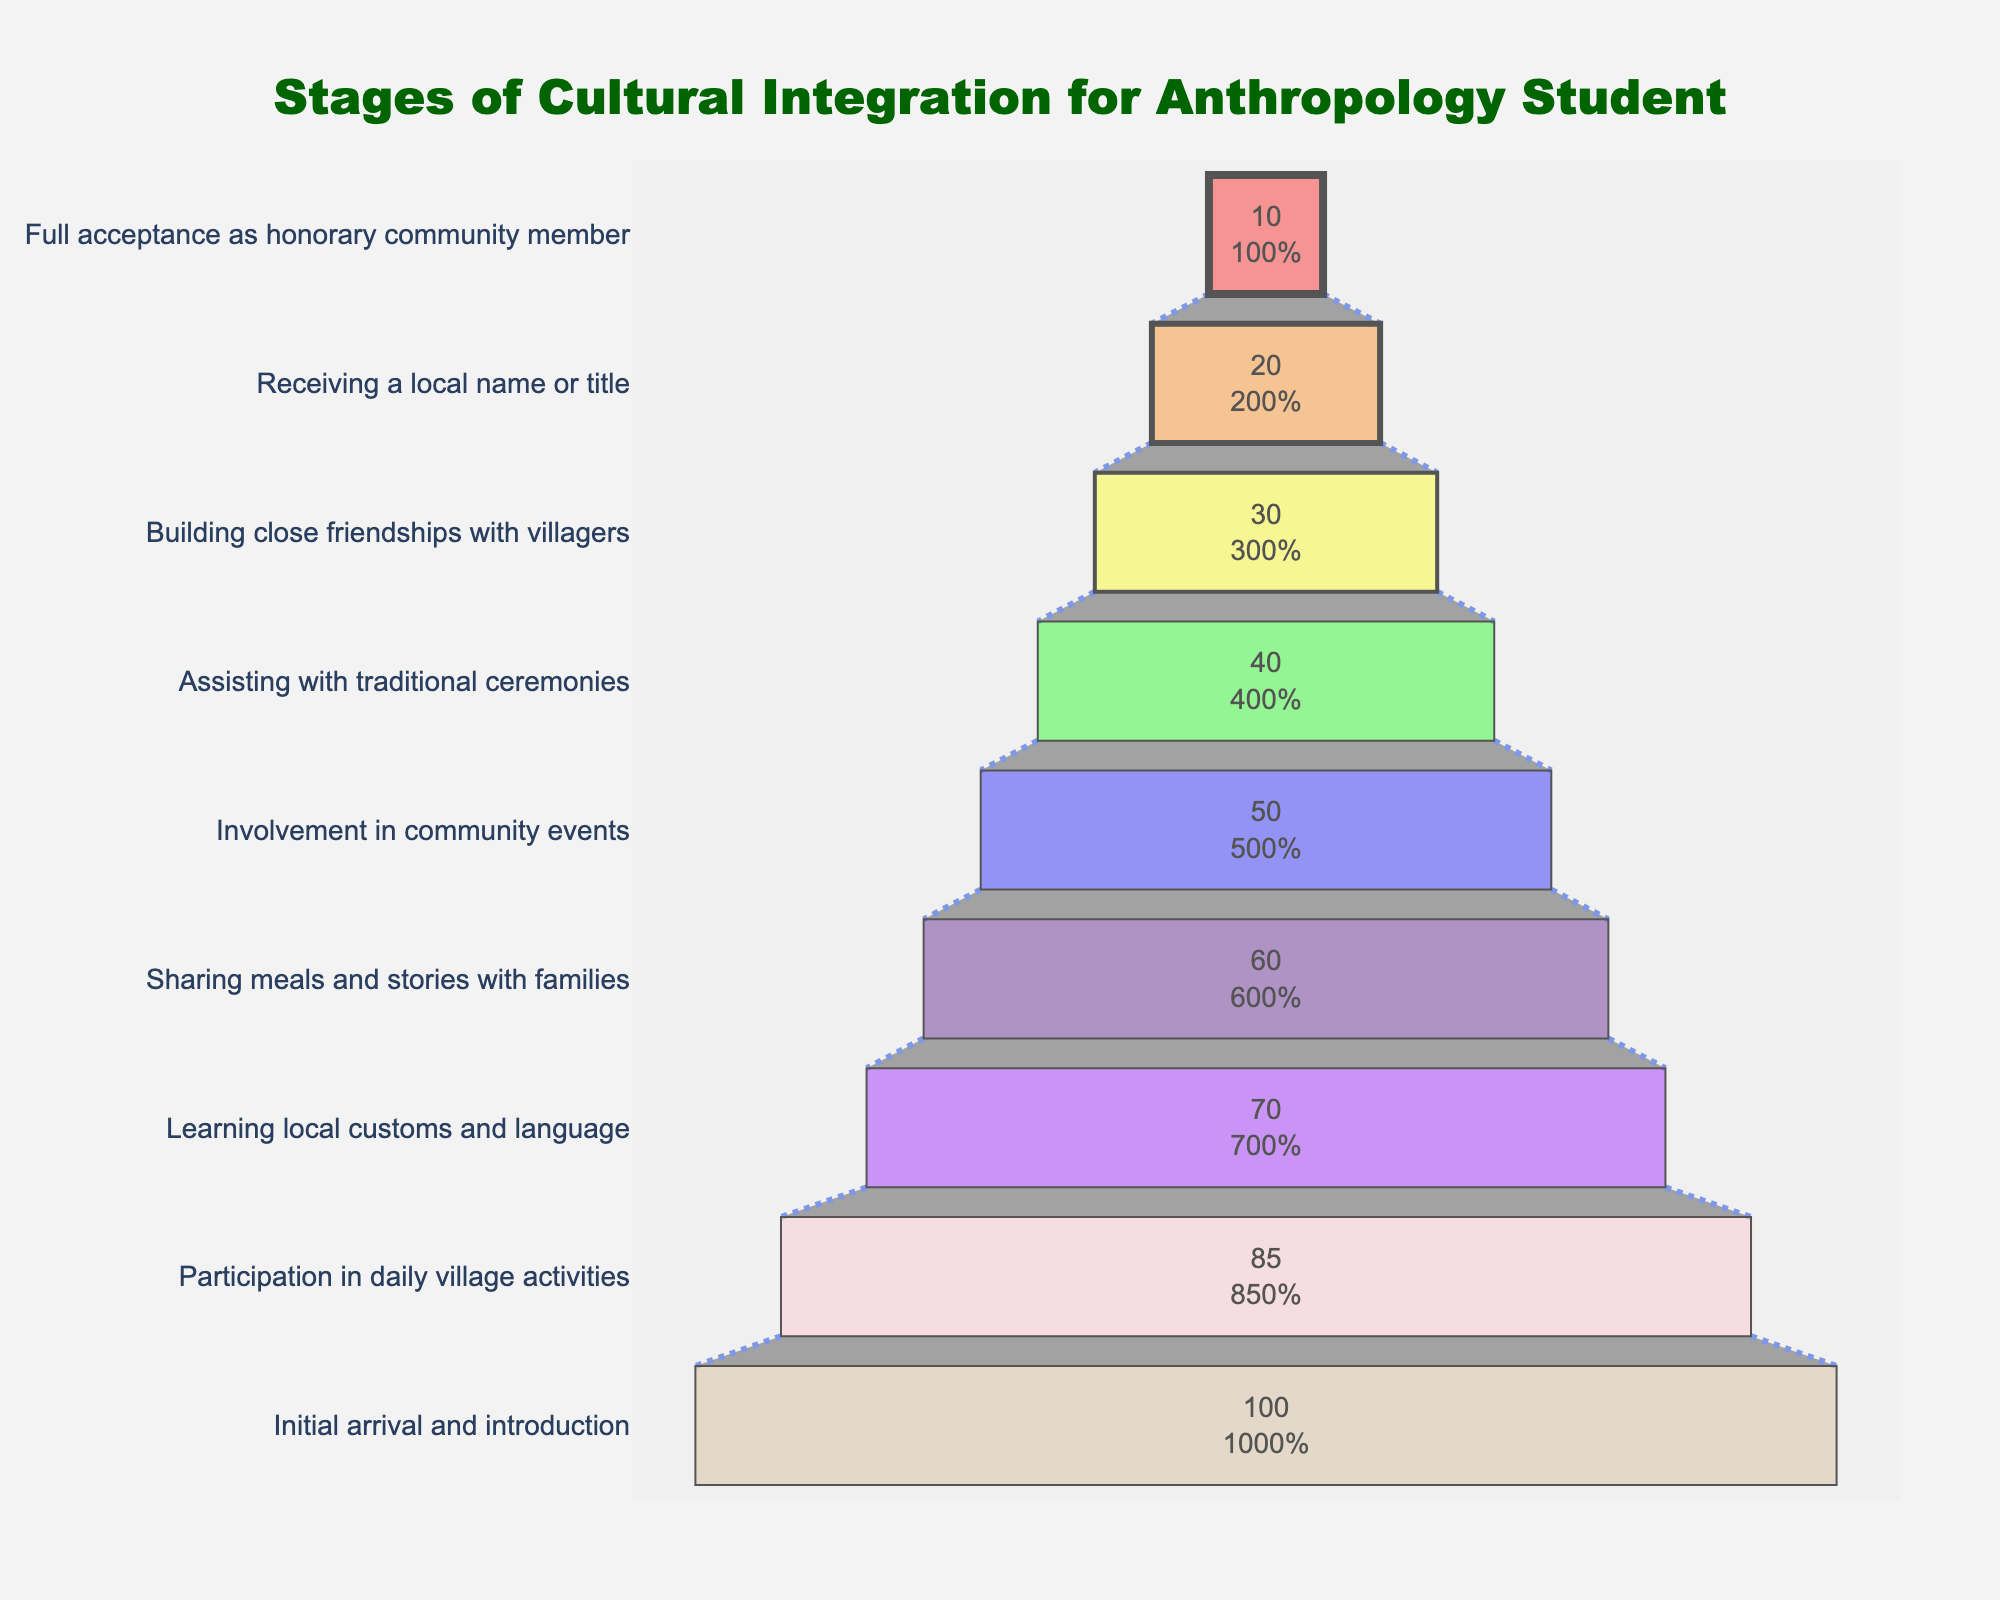What is the title of the chart? The title is written at the top of the chart and is typically bold and larger than other text elements. In this case, it reads "Stages of Cultural Integration for Anthropology Student".
Answer: Stages of Cultural Integration for Anthropology Student How many stages are depicted in the funnel chart? Count the number of unique stages listed along the y-axis.
Answer: 9 Which stage has the highest number of participants? The funnel sections represent stages with varying widths. The widest section at the bottom represents the stage with the highest number of participants.
Answer: Initial arrival and introduction What percentage of participants were involved in community events? Referring to the chart, look for the section labeled "Involvement in community events" and read the percentage text inside this section.
Answer: 50% Compare the number of participants who shared meals and stories with families to those who received a local name or title. Which stage has more participants? Look at the widths of the relevant sections. "Sharing meals and stories with families" should be wider than "Receiving a local name or title".
Answer: Sharing meals and stories with families What is the difference in the number of participants between the initial arrival and full acceptance stages? Subtract the number of participants in the "Full acceptance as honorary community member" stage from the number in the "Initial arrival and introduction" stage (100 - 10).
Answer: 90 What is the median number of participants across all stages? List the number of participants in each stage: 100, 85, 70, 60, 50, 40, 30, 20, 10. Order them and find the middle number (or average the two middle numbers if even). The middle value is (50 + 60)/2.
Answer: 55 How does the number of participants change as you progress through the stages? Observe the funnel layers becoming progressively narrower. Note that the number of participants decreases at each subsequent stage.
Answer: Decreases Between which two stages is the greatest drop in the number of participants observed? Check the differences between adjacent stages. The largest drop is typically indicated by the largest visual reduction in the width of the funnel sections. Calculate: 85 to 70 (15), 70 to 60 (10), 60 to 50 (10)... largest is from Initial arrival (100) to Participation (85).
Answer: Initial arrival and introduction to Participation in daily village activities 